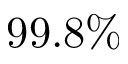Convert formula to latex. <formula><loc_0><loc_0><loc_500><loc_500>9 9 . 8 \%</formula> 